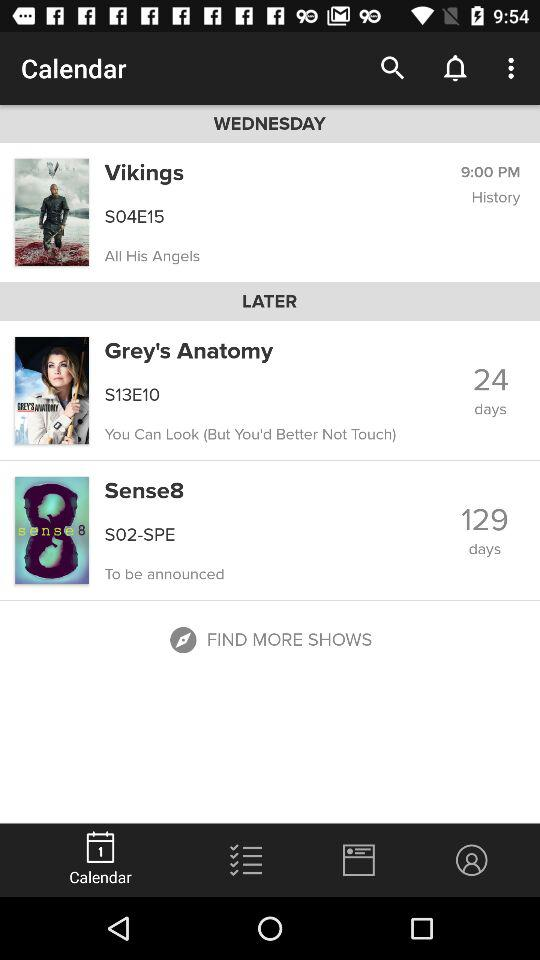How many days until the next episode of Sense8?
Answer the question using a single word or phrase. 129 